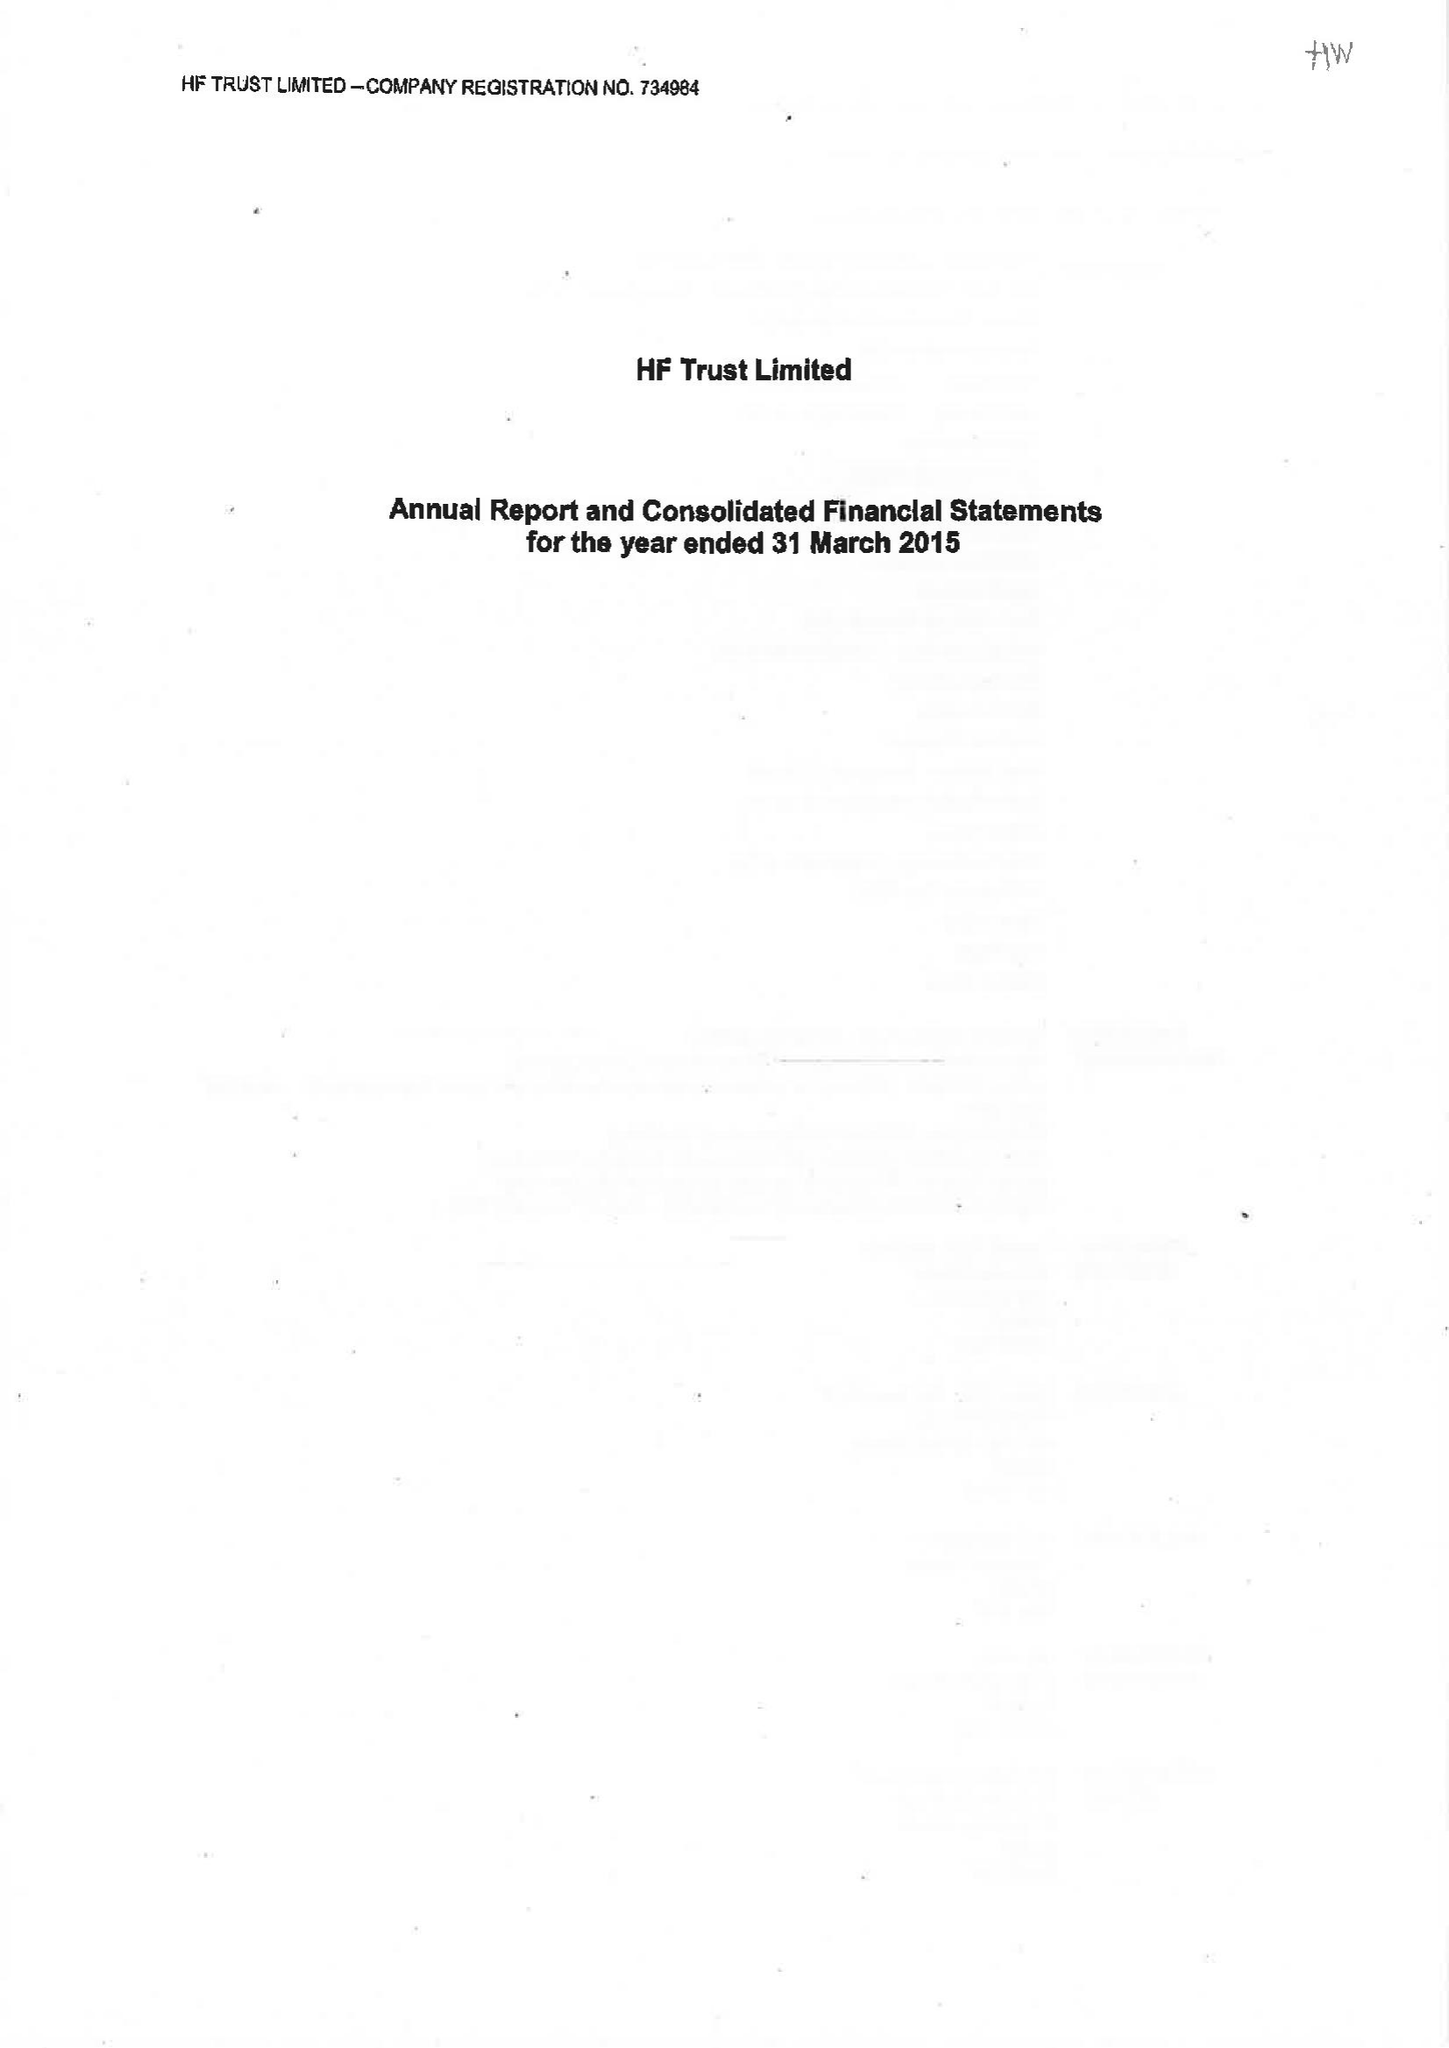What is the value for the report_date?
Answer the question using a single word or phrase. 2015-03-31 